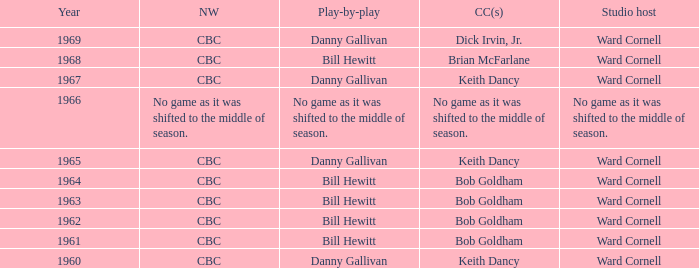Who did the play-by-play on the CBC network before 1961? Danny Gallivan. 